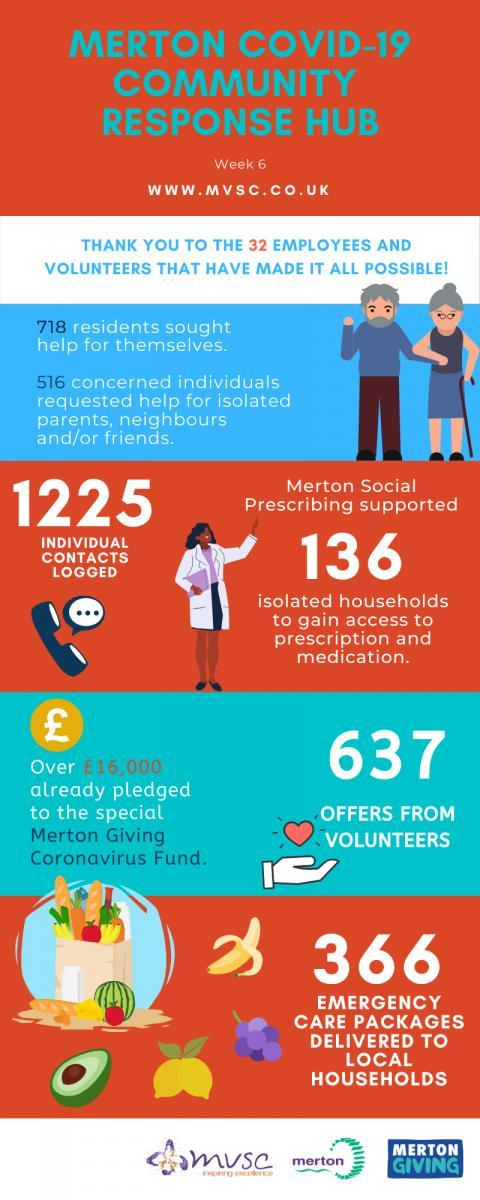What is the name of the account for collecting money for helping corona-virus affected people?
Answer the question with a short phrase. Merton Giving Coronavirus Fund 